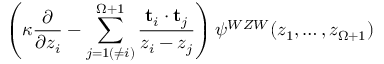Convert formula to latex. <formula><loc_0><loc_0><loc_500><loc_500>\left ( \kappa \frac { \partial } { \partial z _ { i } } - \sum _ { j = 1 ( \neq i ) } ^ { \Omega + 1 } \frac { { t } _ { i } \cdot { t } _ { j } } { z _ { i } - z _ { j } } \right ) \psi ^ { W Z W } ( z _ { 1 } , \dots , z _ { \Omega + 1 } )</formula> 